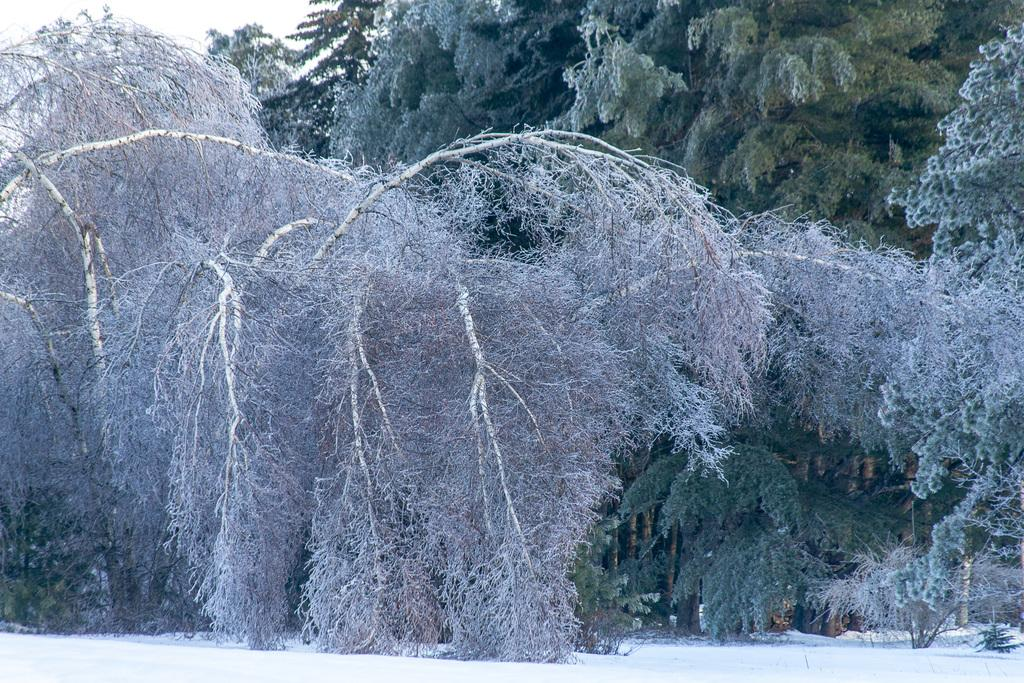What type of vegetation is present in the image? There are trees in the image. What is visible at the top of the image? The sky is visible at the top of the image. What type of weather condition is depicted in the image? There is snow at the bottom of the image, indicating a snowy or wintery condition. What type of soup is being served in the prison class depicted in the image? There is no soup, prison, or class present in the image. The image features trees, snow, and the sky. 